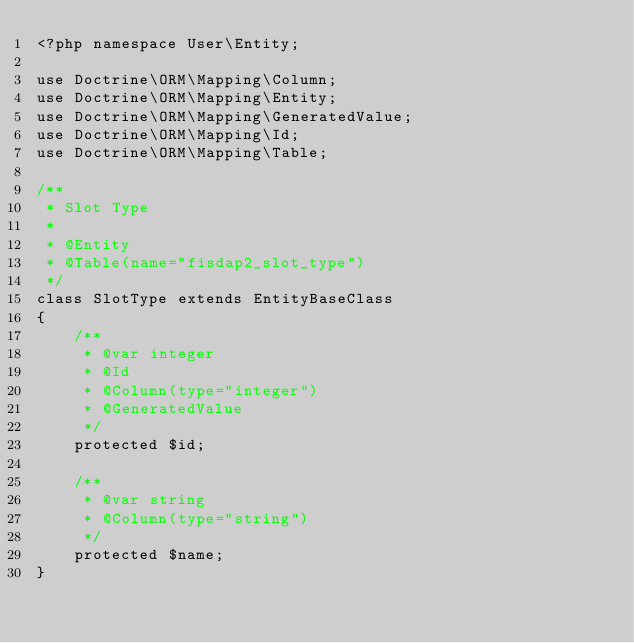<code> <loc_0><loc_0><loc_500><loc_500><_PHP_><?php namespace User\Entity;

use Doctrine\ORM\Mapping\Column;
use Doctrine\ORM\Mapping\Entity;
use Doctrine\ORM\Mapping\GeneratedValue;
use Doctrine\ORM\Mapping\Id;
use Doctrine\ORM\Mapping\Table;

/**
 * Slot Type
 *
 * @Entity
 * @Table(name="fisdap2_slot_type")
 */
class SlotType extends EntityBaseClass
{
    /**
     * @var integer
     * @Id
     * @Column(type="integer")
     * @GeneratedValue
     */
    protected $id;
    
    /**
     * @var string
     * @Column(type="string")
     */
    protected $name;
}
</code> 